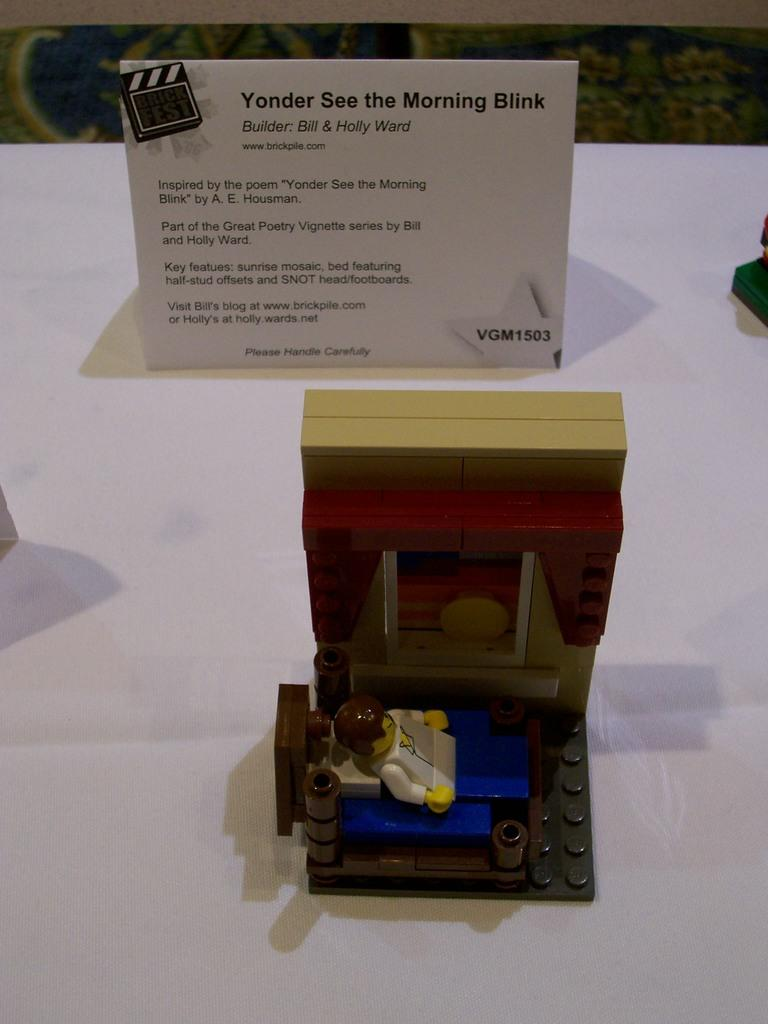<image>
Write a terse but informative summary of the picture. a lego person on display with title Yonder See the Morning Blink 